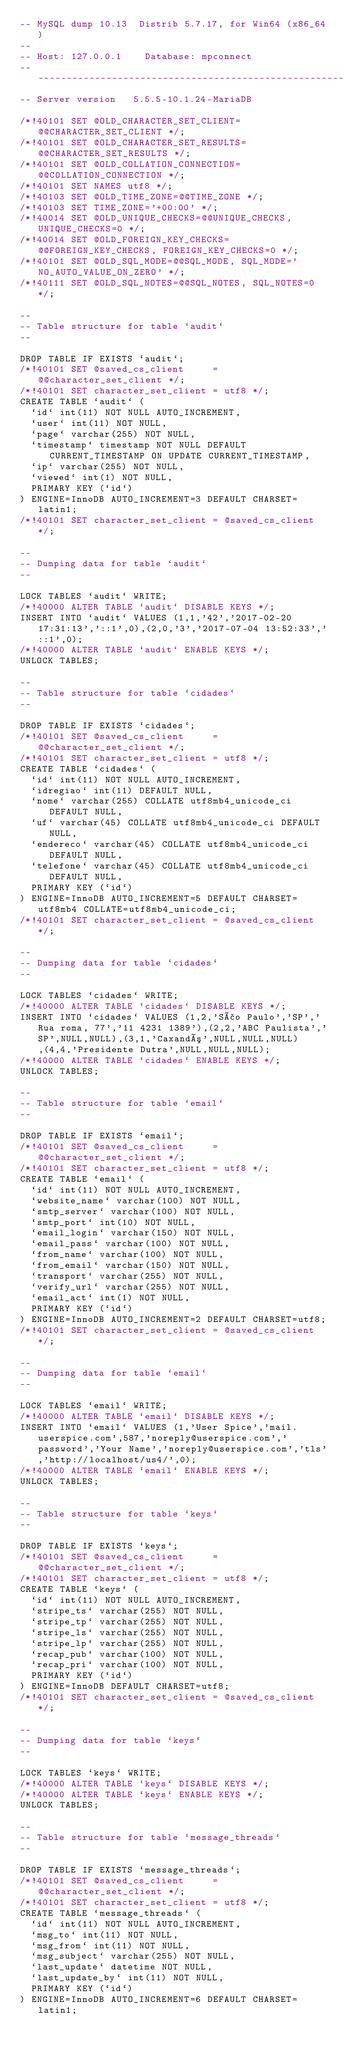<code> <loc_0><loc_0><loc_500><loc_500><_SQL_>-- MySQL dump 10.13  Distrib 5.7.17, for Win64 (x86_64)
--
-- Host: 127.0.0.1    Database: mpconnect
-- ------------------------------------------------------
-- Server version	5.5.5-10.1.24-MariaDB

/*!40101 SET @OLD_CHARACTER_SET_CLIENT=@@CHARACTER_SET_CLIENT */;
/*!40101 SET @OLD_CHARACTER_SET_RESULTS=@@CHARACTER_SET_RESULTS */;
/*!40101 SET @OLD_COLLATION_CONNECTION=@@COLLATION_CONNECTION */;
/*!40101 SET NAMES utf8 */;
/*!40103 SET @OLD_TIME_ZONE=@@TIME_ZONE */;
/*!40103 SET TIME_ZONE='+00:00' */;
/*!40014 SET @OLD_UNIQUE_CHECKS=@@UNIQUE_CHECKS, UNIQUE_CHECKS=0 */;
/*!40014 SET @OLD_FOREIGN_KEY_CHECKS=@@FOREIGN_KEY_CHECKS, FOREIGN_KEY_CHECKS=0 */;
/*!40101 SET @OLD_SQL_MODE=@@SQL_MODE, SQL_MODE='NO_AUTO_VALUE_ON_ZERO' */;
/*!40111 SET @OLD_SQL_NOTES=@@SQL_NOTES, SQL_NOTES=0 */;

--
-- Table structure for table `audit`
--

DROP TABLE IF EXISTS `audit`;
/*!40101 SET @saved_cs_client     = @@character_set_client */;
/*!40101 SET character_set_client = utf8 */;
CREATE TABLE `audit` (
  `id` int(11) NOT NULL AUTO_INCREMENT,
  `user` int(11) NOT NULL,
  `page` varchar(255) NOT NULL,
  `timestamp` timestamp NOT NULL DEFAULT CURRENT_TIMESTAMP ON UPDATE CURRENT_TIMESTAMP,
  `ip` varchar(255) NOT NULL,
  `viewed` int(1) NOT NULL,
  PRIMARY KEY (`id`)
) ENGINE=InnoDB AUTO_INCREMENT=3 DEFAULT CHARSET=latin1;
/*!40101 SET character_set_client = @saved_cs_client */;

--
-- Dumping data for table `audit`
--

LOCK TABLES `audit` WRITE;
/*!40000 ALTER TABLE `audit` DISABLE KEYS */;
INSERT INTO `audit` VALUES (1,1,'42','2017-02-20 17:31:13','::1',0),(2,0,'3','2017-07-04 13:52:33','::1',0);
/*!40000 ALTER TABLE `audit` ENABLE KEYS */;
UNLOCK TABLES;

--
-- Table structure for table `cidades`
--

DROP TABLE IF EXISTS `cidades`;
/*!40101 SET @saved_cs_client     = @@character_set_client */;
/*!40101 SET character_set_client = utf8 */;
CREATE TABLE `cidades` (
  `id` int(11) NOT NULL AUTO_INCREMENT,
  `idregiao` int(11) DEFAULT NULL,
  `nome` varchar(255) COLLATE utf8mb4_unicode_ci DEFAULT NULL,
  `uf` varchar(45) COLLATE utf8mb4_unicode_ci DEFAULT NULL,
  `endereco` varchar(45) COLLATE utf8mb4_unicode_ci DEFAULT NULL,
  `telefone` varchar(45) COLLATE utf8mb4_unicode_ci DEFAULT NULL,
  PRIMARY KEY (`id`)
) ENGINE=InnoDB AUTO_INCREMENT=5 DEFAULT CHARSET=utf8mb4 COLLATE=utf8mb4_unicode_ci;
/*!40101 SET character_set_client = @saved_cs_client */;

--
-- Dumping data for table `cidades`
--

LOCK TABLES `cidades` WRITE;
/*!40000 ALTER TABLE `cidades` DISABLE KEYS */;
INSERT INTO `cidades` VALUES (1,2,'São Paulo','SP','Rua roma, 77','11 4231 1389'),(2,2,'ABC Paulista','SP',NULL,NULL),(3,1,'Caxandó',NULL,NULL,NULL),(4,4,'Presidente Dutra',NULL,NULL,NULL);
/*!40000 ALTER TABLE `cidades` ENABLE KEYS */;
UNLOCK TABLES;

--
-- Table structure for table `email`
--

DROP TABLE IF EXISTS `email`;
/*!40101 SET @saved_cs_client     = @@character_set_client */;
/*!40101 SET character_set_client = utf8 */;
CREATE TABLE `email` (
  `id` int(11) NOT NULL AUTO_INCREMENT,
  `website_name` varchar(100) NOT NULL,
  `smtp_server` varchar(100) NOT NULL,
  `smtp_port` int(10) NOT NULL,
  `email_login` varchar(150) NOT NULL,
  `email_pass` varchar(100) NOT NULL,
  `from_name` varchar(100) NOT NULL,
  `from_email` varchar(150) NOT NULL,
  `transport` varchar(255) NOT NULL,
  `verify_url` varchar(255) NOT NULL,
  `email_act` int(1) NOT NULL,
  PRIMARY KEY (`id`)
) ENGINE=InnoDB AUTO_INCREMENT=2 DEFAULT CHARSET=utf8;
/*!40101 SET character_set_client = @saved_cs_client */;

--
-- Dumping data for table `email`
--

LOCK TABLES `email` WRITE;
/*!40000 ALTER TABLE `email` DISABLE KEYS */;
INSERT INTO `email` VALUES (1,'User Spice','mail.userspice.com',587,'noreply@userspice.com','password','Your Name','noreply@userspice.com','tls','http://localhost/us4/',0);
/*!40000 ALTER TABLE `email` ENABLE KEYS */;
UNLOCK TABLES;

--
-- Table structure for table `keys`
--

DROP TABLE IF EXISTS `keys`;
/*!40101 SET @saved_cs_client     = @@character_set_client */;
/*!40101 SET character_set_client = utf8 */;
CREATE TABLE `keys` (
  `id` int(11) NOT NULL AUTO_INCREMENT,
  `stripe_ts` varchar(255) NOT NULL,
  `stripe_tp` varchar(255) NOT NULL,
  `stripe_ls` varchar(255) NOT NULL,
  `stripe_lp` varchar(255) NOT NULL,
  `recap_pub` varchar(100) NOT NULL,
  `recap_pri` varchar(100) NOT NULL,
  PRIMARY KEY (`id`)
) ENGINE=InnoDB DEFAULT CHARSET=utf8;
/*!40101 SET character_set_client = @saved_cs_client */;

--
-- Dumping data for table `keys`
--

LOCK TABLES `keys` WRITE;
/*!40000 ALTER TABLE `keys` DISABLE KEYS */;
/*!40000 ALTER TABLE `keys` ENABLE KEYS */;
UNLOCK TABLES;

--
-- Table structure for table `message_threads`
--

DROP TABLE IF EXISTS `message_threads`;
/*!40101 SET @saved_cs_client     = @@character_set_client */;
/*!40101 SET character_set_client = utf8 */;
CREATE TABLE `message_threads` (
  `id` int(11) NOT NULL AUTO_INCREMENT,
  `msg_to` int(11) NOT NULL,
  `msg_from` int(11) NOT NULL,
  `msg_subject` varchar(255) NOT NULL,
  `last_update` datetime NOT NULL,
  `last_update_by` int(11) NOT NULL,
  PRIMARY KEY (`id`)
) ENGINE=InnoDB AUTO_INCREMENT=6 DEFAULT CHARSET=latin1;</code> 